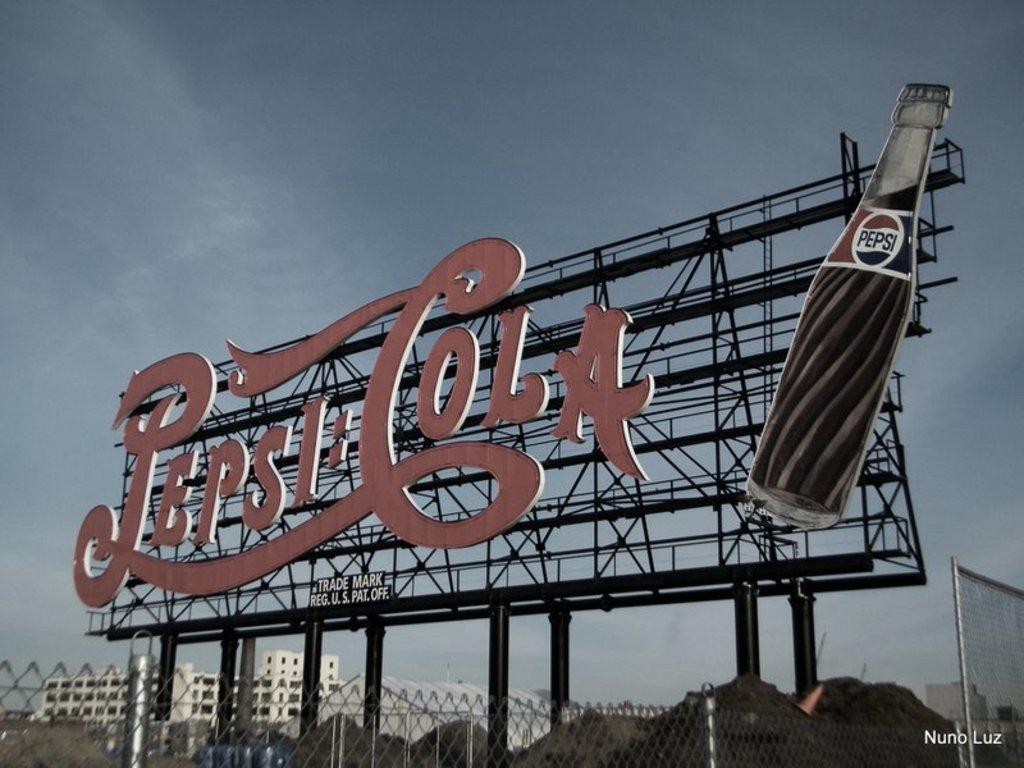What is written on the neck of the bottle on this sign?
Offer a terse response. Pepsi. What is the ad for?
Provide a succinct answer. Pepsi cola. 